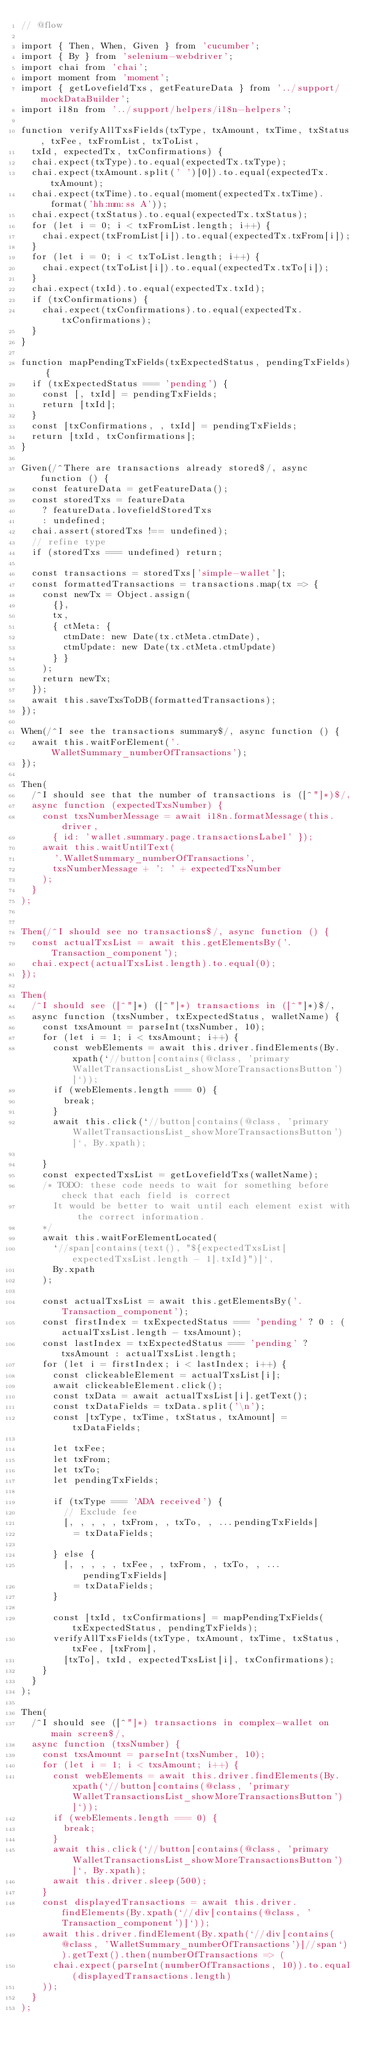Convert code to text. <code><loc_0><loc_0><loc_500><loc_500><_JavaScript_>// @flow

import { Then, When, Given } from 'cucumber';
import { By } from 'selenium-webdriver';
import chai from 'chai';
import moment from 'moment';
import { getLovefieldTxs, getFeatureData } from '../support/mockDataBuilder';
import i18n from '../support/helpers/i18n-helpers';

function verifyAllTxsFields(txType, txAmount, txTime, txStatus, txFee, txFromList, txToList,
  txId, expectedTx, txConfirmations) {
  chai.expect(txType).to.equal(expectedTx.txType);
  chai.expect(txAmount.split(' ')[0]).to.equal(expectedTx.txAmount);
  chai.expect(txTime).to.equal(moment(expectedTx.txTime).format('hh:mm:ss A'));
  chai.expect(txStatus).to.equal(expectedTx.txStatus);
  for (let i = 0; i < txFromList.length; i++) {
    chai.expect(txFromList[i]).to.equal(expectedTx.txFrom[i]);
  }
  for (let i = 0; i < txToList.length; i++) {
    chai.expect(txToList[i]).to.equal(expectedTx.txTo[i]);
  }
  chai.expect(txId).to.equal(expectedTx.txId);
  if (txConfirmations) {
    chai.expect(txConfirmations).to.equal(expectedTx.txConfirmations);
  }
}

function mapPendingTxFields(txExpectedStatus, pendingTxFields) {
  if (txExpectedStatus === 'pending') {
    const [, txId] = pendingTxFields;
    return [txId];
  }
  const [txConfirmations, , txId] = pendingTxFields;
  return [txId, txConfirmations];
}

Given(/^There are transactions already stored$/, async function () {
  const featureData = getFeatureData();
  const storedTxs = featureData
    ? featureData.lovefieldStoredTxs
    : undefined;
  chai.assert(storedTxs !== undefined);
  // refine type
  if (storedTxs === undefined) return;

  const transactions = storedTxs['simple-wallet'];
  const formattedTransactions = transactions.map(tx => {
    const newTx = Object.assign(
      {},
      tx,
      { ctMeta: {
        ctmDate: new Date(tx.ctMeta.ctmDate),
        ctmUpdate: new Date(tx.ctMeta.ctmUpdate)
      } }
    );
    return newTx;
  });
  await this.saveTxsToDB(formattedTransactions);
});

When(/^I see the transactions summary$/, async function () {
  await this.waitForElement('.WalletSummary_numberOfTransactions');
});

Then(
  /^I should see that the number of transactions is ([^"]*)$/,
  async function (expectedTxsNumber) {
    const txsNumberMessage = await i18n.formatMessage(this.driver,
      { id: 'wallet.summary.page.transactionsLabel' });
    await this.waitUntilText(
      '.WalletSummary_numberOfTransactions',
      txsNumberMessage + ': ' + expectedTxsNumber
    );
  }
);


Then(/^I should see no transactions$/, async function () {
  const actualTxsList = await this.getElementsBy('.Transaction_component');
  chai.expect(actualTxsList.length).to.equal(0);
});

Then(
  /^I should see ([^"]*) ([^"]*) transactions in ([^"]*)$/,
  async function (txsNumber, txExpectedStatus, walletName) {
    const txsAmount = parseInt(txsNumber, 10);
    for (let i = 1; i < txsAmount; i++) {
      const webElements = await this.driver.findElements(By.xpath(`//button[contains(@class, 'primary WalletTransactionsList_showMoreTransactionsButton')]`));
      if (webElements.length === 0) {
        break;
      }
      await this.click(`//button[contains(@class, 'primary WalletTransactionsList_showMoreTransactionsButton')]`, By.xpath);

    }
    const expectedTxsList = getLovefieldTxs(walletName);
    /* TODO: these code needs to wait for something before check that each field is correct
      It would be better to wait until each element exist with the correct information.
    */
    await this.waitForElementLocated(
      `//span[contains(text(), "${expectedTxsList[expectedTxsList.length - 1].txId}")]`,
      By.xpath
    );

    const actualTxsList = await this.getElementsBy('.Transaction_component');
    const firstIndex = txExpectedStatus === 'pending' ? 0 : (actualTxsList.length - txsAmount);
    const lastIndex = txExpectedStatus === 'pending' ? txsAmount : actualTxsList.length;
    for (let i = firstIndex; i < lastIndex; i++) {
      const clickeableElement = actualTxsList[i];
      await clickeableElement.click();
      const txData = await actualTxsList[i].getText();
      const txDataFields = txData.split('\n');
      const [txType, txTime, txStatus, txAmount] = txDataFields;

      let txFee;
      let txFrom;
      let txTo;
      let pendingTxFields;

      if (txType === 'ADA received') {
        // Exclude fee
        [, , , , , txFrom, , txTo, , ...pendingTxFields]
          = txDataFields;

      } else {
        [, , , , , txFee, , txFrom, , txTo, , ...pendingTxFields]
          = txDataFields;
      }

      const [txId, txConfirmations] = mapPendingTxFields(txExpectedStatus, pendingTxFields);
      verifyAllTxsFields(txType, txAmount, txTime, txStatus, txFee, [txFrom],
        [txTo], txId, expectedTxsList[i], txConfirmations);
    }
  }
);

Then(
  /^I should see ([^"]*) transactions in complex-wallet on main screen$/,
  async function (txsNumber) {
    const txsAmount = parseInt(txsNumber, 10);
    for (let i = 1; i < txsAmount; i++) {
      const webElements = await this.driver.findElements(By.xpath(`//button[contains(@class, 'primary WalletTransactionsList_showMoreTransactionsButton')]`));
      if (webElements.length === 0) {
        break;
      }
      await this.click(`//button[contains(@class, 'primary WalletTransactionsList_showMoreTransactionsButton')]`, By.xpath);
      await this.driver.sleep(500);
    }
    const displayedTransactions = await this.driver.findElements(By.xpath(`//div[contains(@class, 'Transaction_component')]`));
    await this.driver.findElement(By.xpath(`//div[contains(@class, 'WalletSummary_numberOfTransactions')]//span`)).getText().then(numberOfTransactions => (
      chai.expect(parseInt(numberOfTransactions, 10)).to.equal(displayedTransactions.length)
    ));
  }
);
</code> 